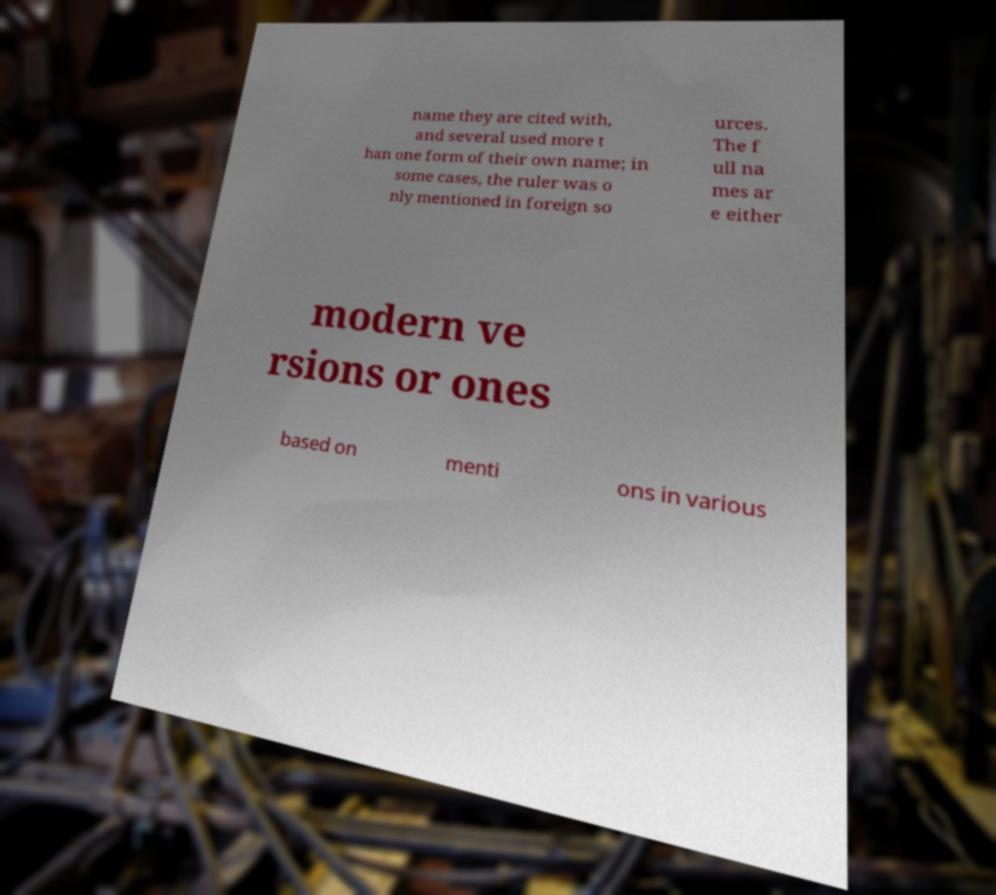Could you assist in decoding the text presented in this image and type it out clearly? name they are cited with, and several used more t han one form of their own name; in some cases, the ruler was o nly mentioned in foreign so urces. The f ull na mes ar e either modern ve rsions or ones based on menti ons in various 